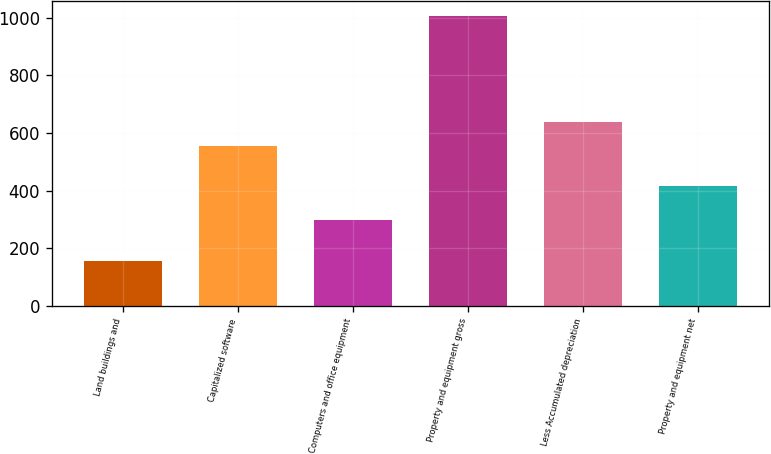Convert chart. <chart><loc_0><loc_0><loc_500><loc_500><bar_chart><fcel>Land buildings and<fcel>Capitalized software<fcel>Computers and office equipment<fcel>Property and equipment gross<fcel>Less Accumulated depreciation<fcel>Property and equipment net<nl><fcel>155.5<fcel>553.6<fcel>298.6<fcel>1007.7<fcel>638.82<fcel>416.2<nl></chart> 